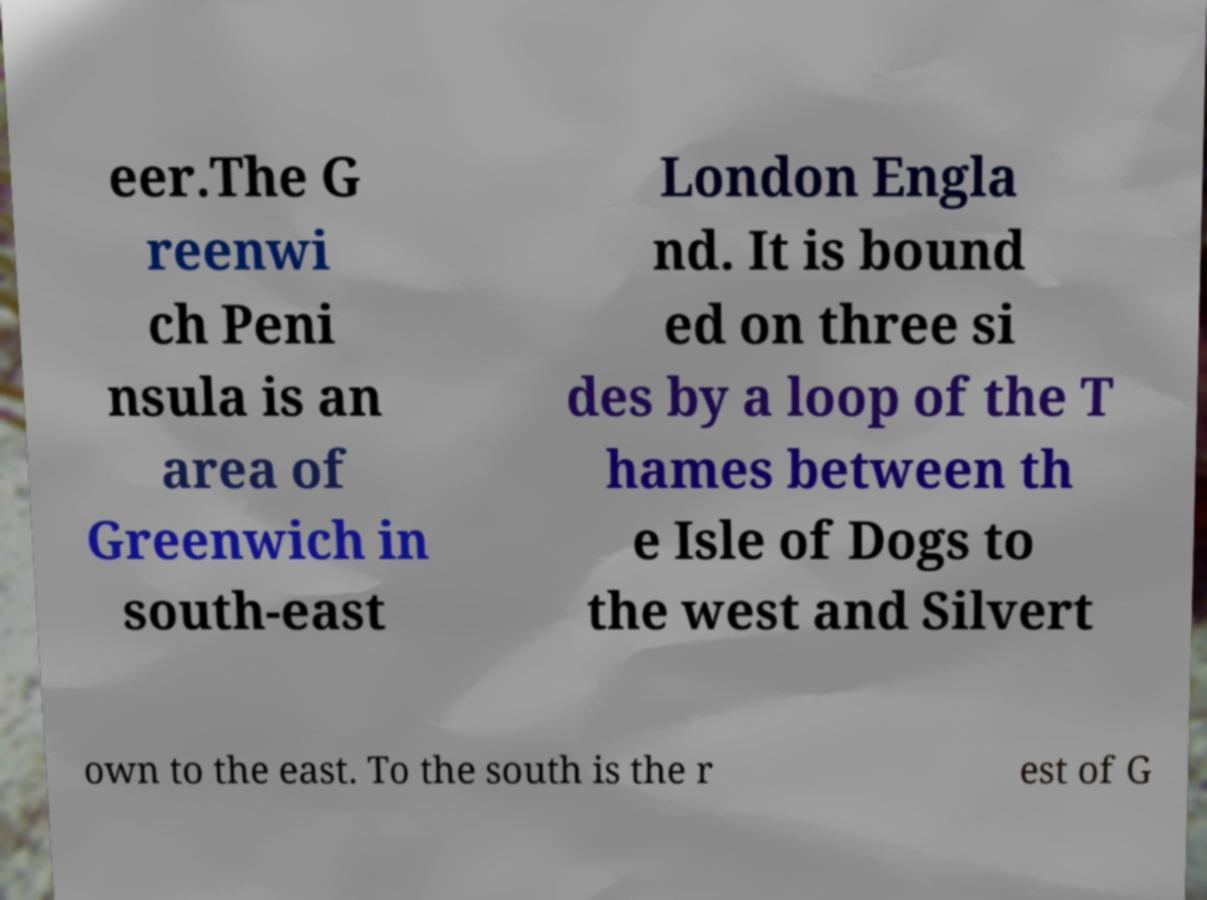What messages or text are displayed in this image? I need them in a readable, typed format. eer.The G reenwi ch Peni nsula is an area of Greenwich in south-east London Engla nd. It is bound ed on three si des by a loop of the T hames between th e Isle of Dogs to the west and Silvert own to the east. To the south is the r est of G 